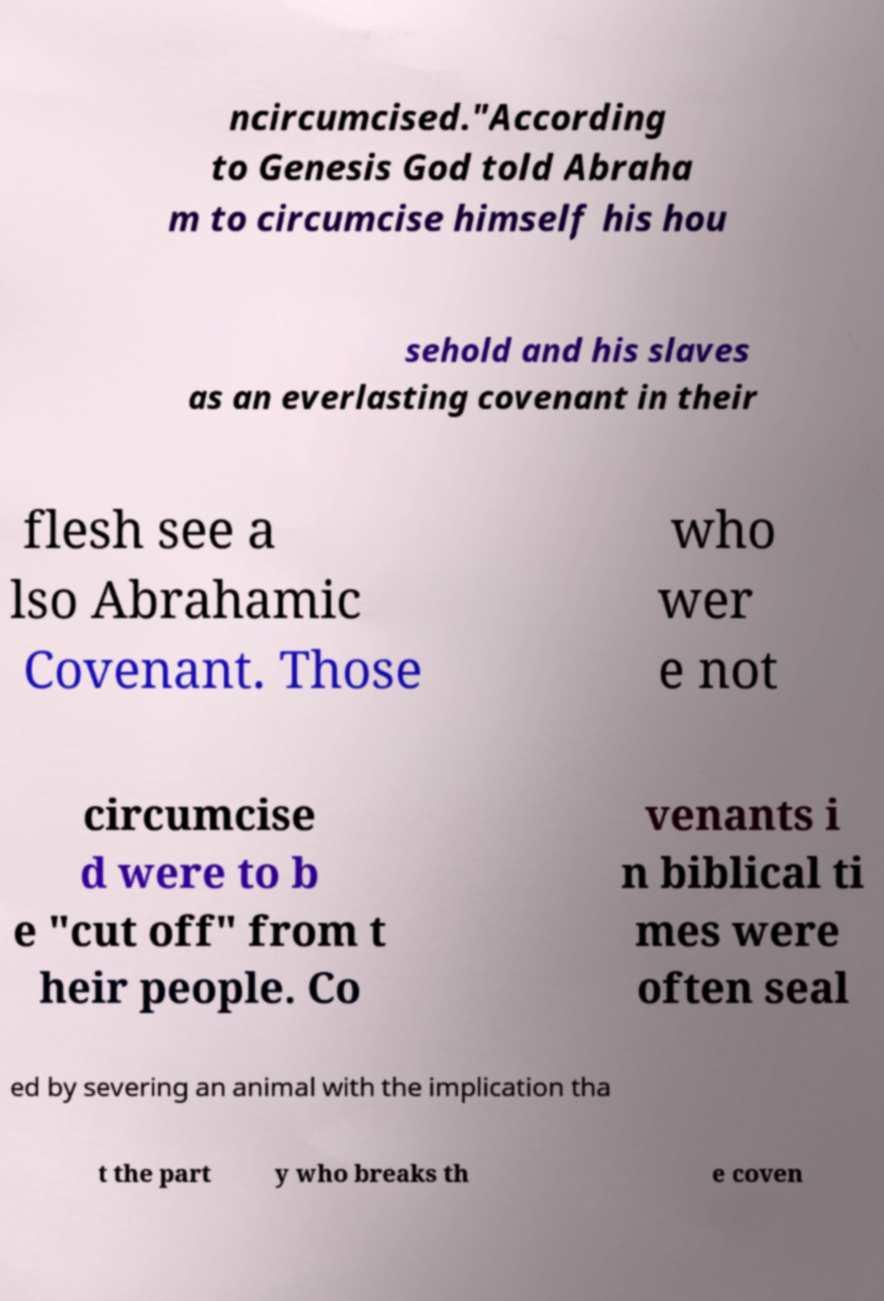Could you assist in decoding the text presented in this image and type it out clearly? ncircumcised."According to Genesis God told Abraha m to circumcise himself his hou sehold and his slaves as an everlasting covenant in their flesh see a lso Abrahamic Covenant. Those who wer e not circumcise d were to b e "cut off" from t heir people. Co venants i n biblical ti mes were often seal ed by severing an animal with the implication tha t the part y who breaks th e coven 